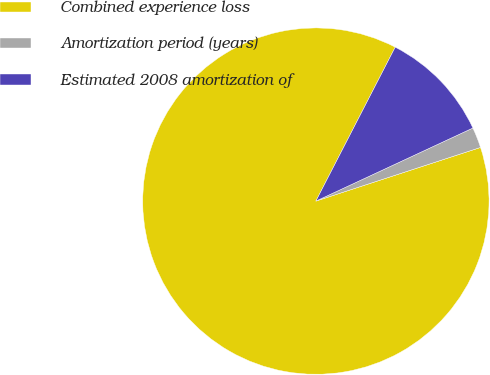Convert chart to OTSL. <chart><loc_0><loc_0><loc_500><loc_500><pie_chart><fcel>Combined experience loss<fcel>Amortization period (years)<fcel>Estimated 2008 amortization of<nl><fcel>87.59%<fcel>1.92%<fcel>10.49%<nl></chart> 